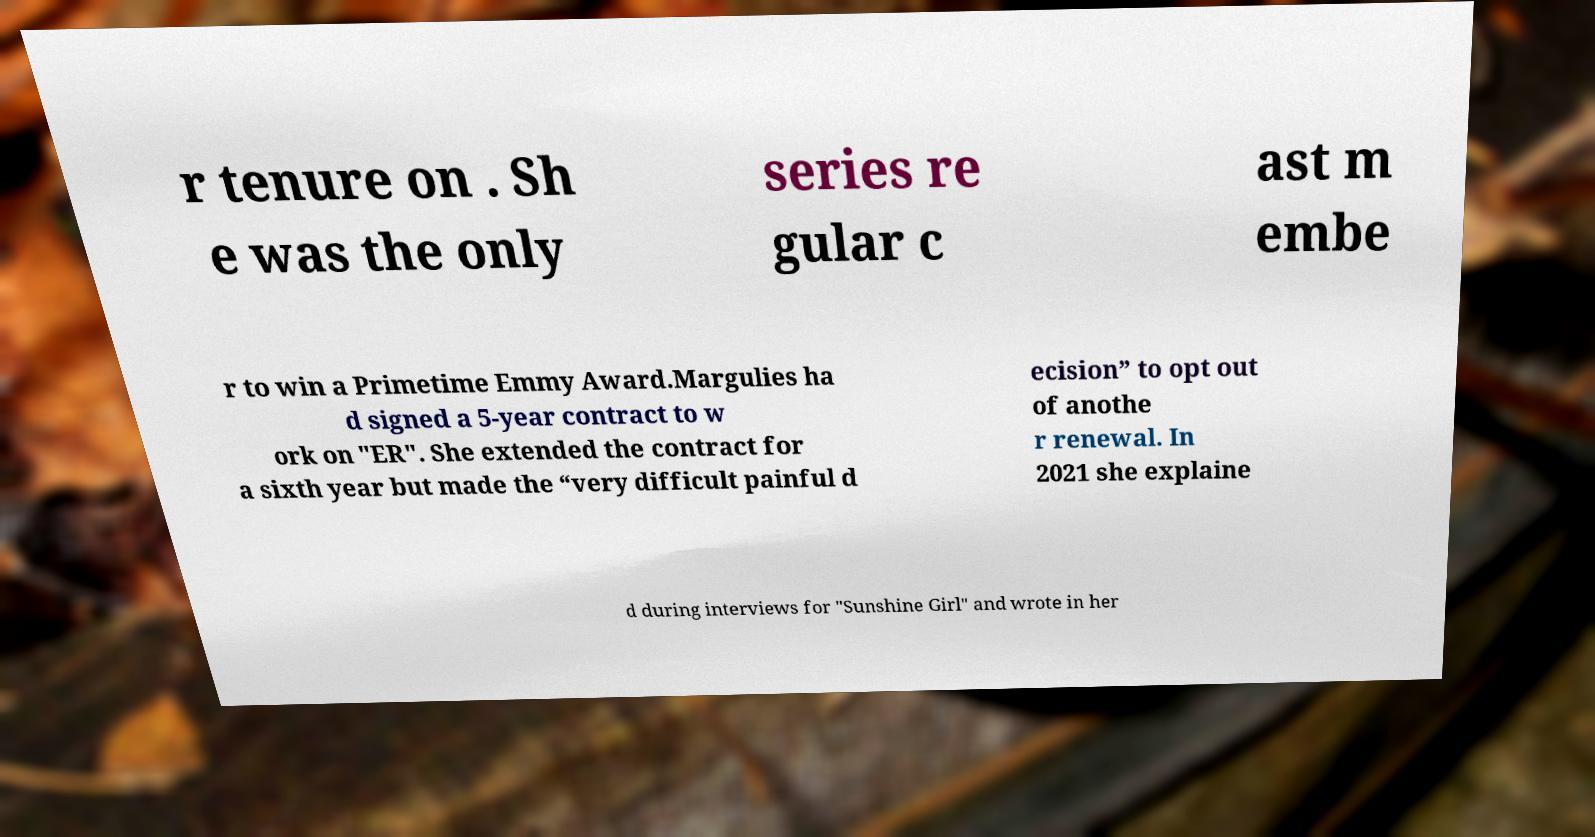Please read and relay the text visible in this image. What does it say? r tenure on . Sh e was the only series re gular c ast m embe r to win a Primetime Emmy Award.Margulies ha d signed a 5-year contract to w ork on "ER". She extended the contract for a sixth year but made the “very difficult painful d ecision” to opt out of anothe r renewal. In 2021 she explaine d during interviews for "Sunshine Girl" and wrote in her 